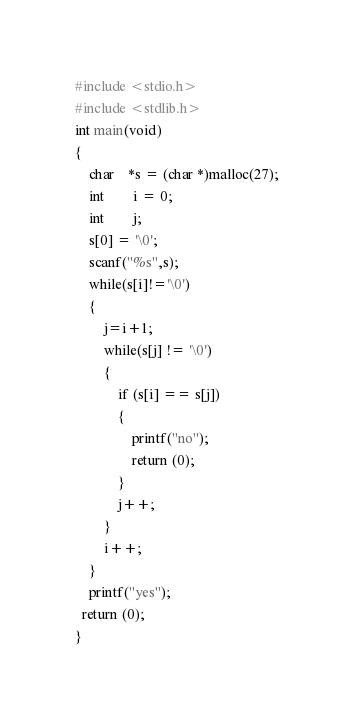<code> <loc_0><loc_0><loc_500><loc_500><_C_>#include <stdio.h>
#include <stdlib.h>
int main(void)
{
	char	*s = (char *)malloc(27);
	int		i = 0;
	int		j;
	s[0] = '\0';
	scanf("%s",s);  
	while(s[i]!='\0')
	{
		j=i+1;
		while(s[j] != '\0')
		{
			if (s[i] == s[j])
			{
				printf("no");
				return (0);
			}
			j++;
		}
		i++;
	}
	printf("yes");
  return (0);
}</code> 